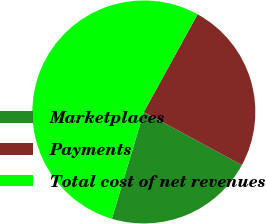Convert chart. <chart><loc_0><loc_0><loc_500><loc_500><pie_chart><fcel>Marketplaces<fcel>Payments<fcel>Total cost of net revenues<nl><fcel>21.73%<fcel>24.89%<fcel>53.37%<nl></chart> 